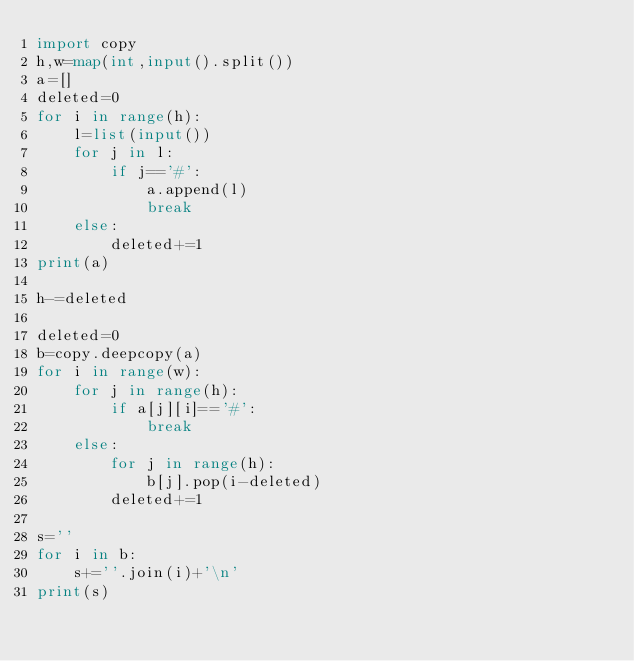<code> <loc_0><loc_0><loc_500><loc_500><_Python_>import copy
h,w=map(int,input().split())
a=[]
deleted=0
for i in range(h):
    l=list(input())
    for j in l:
        if j=='#':
            a.append(l)
            break
    else:
        deleted+=1
print(a)

h-=deleted

deleted=0
b=copy.deepcopy(a)
for i in range(w):
    for j in range(h):
        if a[j][i]=='#':
            break
    else:
        for j in range(h):
            b[j].pop(i-deleted)
        deleted+=1

s=''
for i in b:
    s+=''.join(i)+'\n'
print(s)</code> 